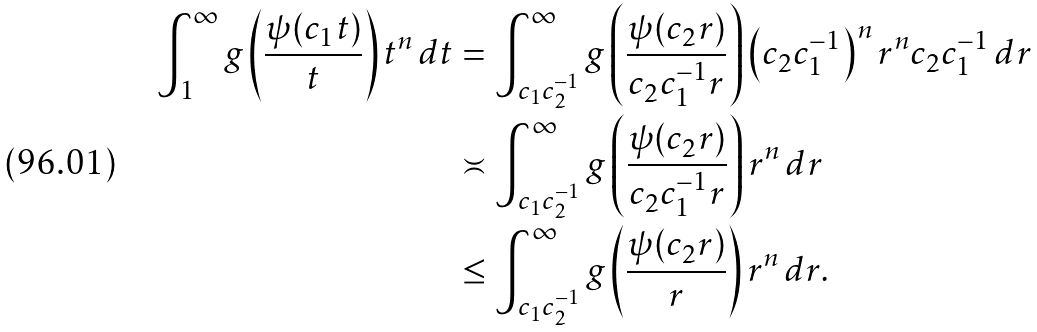<formula> <loc_0><loc_0><loc_500><loc_500>\int _ { 1 } ^ { \infty } g \left ( \frac { \psi ( c _ { 1 } t ) } { t } \right ) t ^ { n } \, d t & = \int _ { c _ { 1 } c _ { 2 } ^ { - 1 } } ^ { \infty } g \left ( \frac { \psi ( c _ { 2 } r ) } { c _ { 2 } c _ { 1 } ^ { - 1 } r } \right ) \left ( c _ { 2 } c _ { 1 } ^ { - 1 } \right ) ^ { n } r ^ { n } c _ { 2 } c _ { 1 } ^ { - 1 } \, d r \\ & \asymp \int _ { c _ { 1 } c _ { 2 } ^ { - 1 } } ^ { \infty } g \left ( \frac { \psi ( c _ { 2 } r ) } { c _ { 2 } c _ { 1 } ^ { - 1 } r } \right ) r ^ { n } \, d r \\ & \leq \int _ { c _ { 1 } c _ { 2 } ^ { - 1 } } ^ { \infty } g \left ( \frac { \psi ( c _ { 2 } r ) } { r } \right ) r ^ { n } \, d r .</formula> 